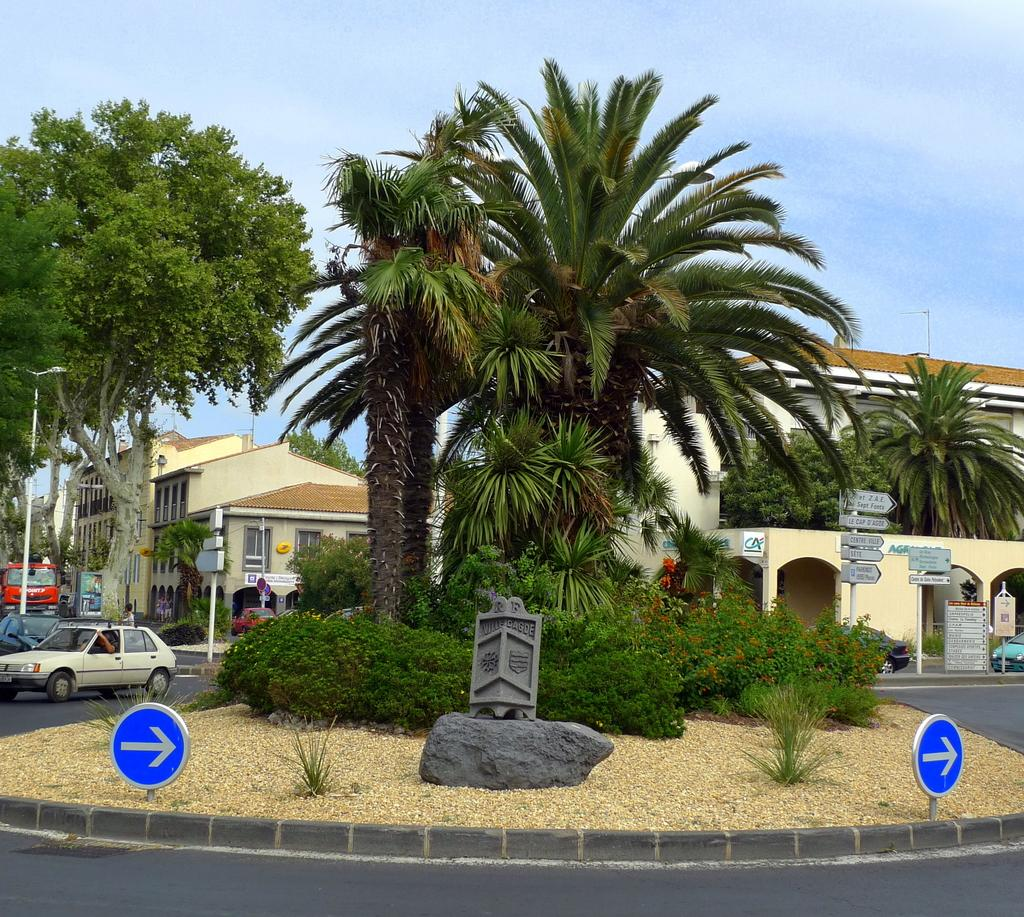What type of vegetation is present in the image? There are palm trees in the image. What is located on either side of the palm trees? There is a road on either side of the palm trees. What can be seen on the left side of the image? There is a car on the left side of the image. What is visible in the background of the image? There are buildings in the background of the image. What is visible above the buildings? The sky is visible above the buildings. What type of cabbage is being served on a tray in the image? There is no cabbage or tray present in the image. What color are the roses on the right side of the image? There are no roses present in the image. 